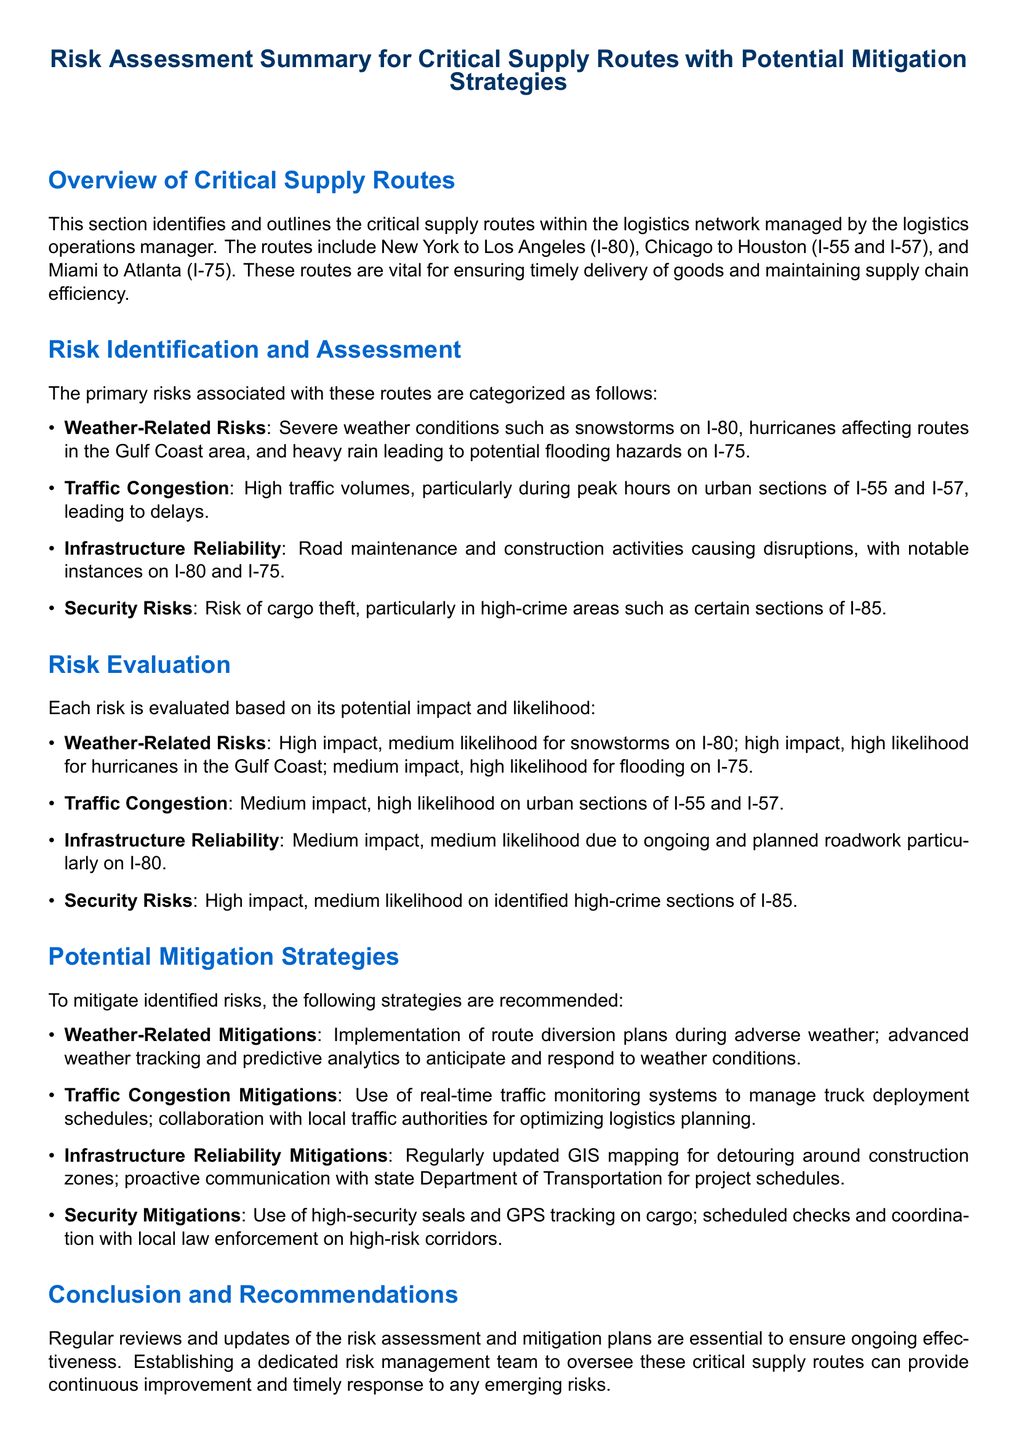What are the critical supply routes? The critical supply routes are listed in the overview section of the document, which includes New York to Los Angeles, Chicago to Houston, and Miami to Atlanta.
Answer: New York to Los Angeles, Chicago to Houston, Miami to Atlanta What type of risks are identified? The document categorizes the risks into four types: Weather-Related Risks, Traffic Congestion, Infrastructure Reliability, and Security Risks.
Answer: Weather-Related Risks, Traffic Congestion, Infrastructure Reliability, Security Risks What is the likelihood of hurricanes affecting the Gulf Coast? According to the risk evaluation section, the likelihood of hurricanes in the Gulf Coast is classified as high.
Answer: High What mitigation strategies are suggested for weather-related risks? The document recommends implementation of route diversion plans and advanced weather tracking for weather-related risks.
Answer: Route diversion plans, advanced weather tracking What section addresses the conclusion and recommendations? The conclusion and recommendations section summarizes the importance of regular reviews and establishing a dedicated risk management team.
Answer: Conclusion and Recommendations What risk has medium impact and high likelihood? The risk associated with traffic congestion on urban sections of I-55 and I-57 is evaluated as medium impact and high likelihood.
Answer: Traffic Congestion How many risks are categorized? The document outlines four main categories of risk related to critical supply routes.
Answer: Four What is a suggested method for enhancing security on high-risk corridors? The document suggests using high-security seals and GPS tracking on cargo as a security enhancement method.
Answer: High-security seals, GPS tracking What is the evaluated impact level of flooding on I-75? The impact level of flooding on I-75 is evaluated as medium.
Answer: Medium 